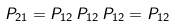Convert formula to latex. <formula><loc_0><loc_0><loc_500><loc_500>P _ { 2 1 } = P _ { 1 2 } \, P _ { 1 2 } \, P _ { 1 2 } = P _ { 1 2 }</formula> 